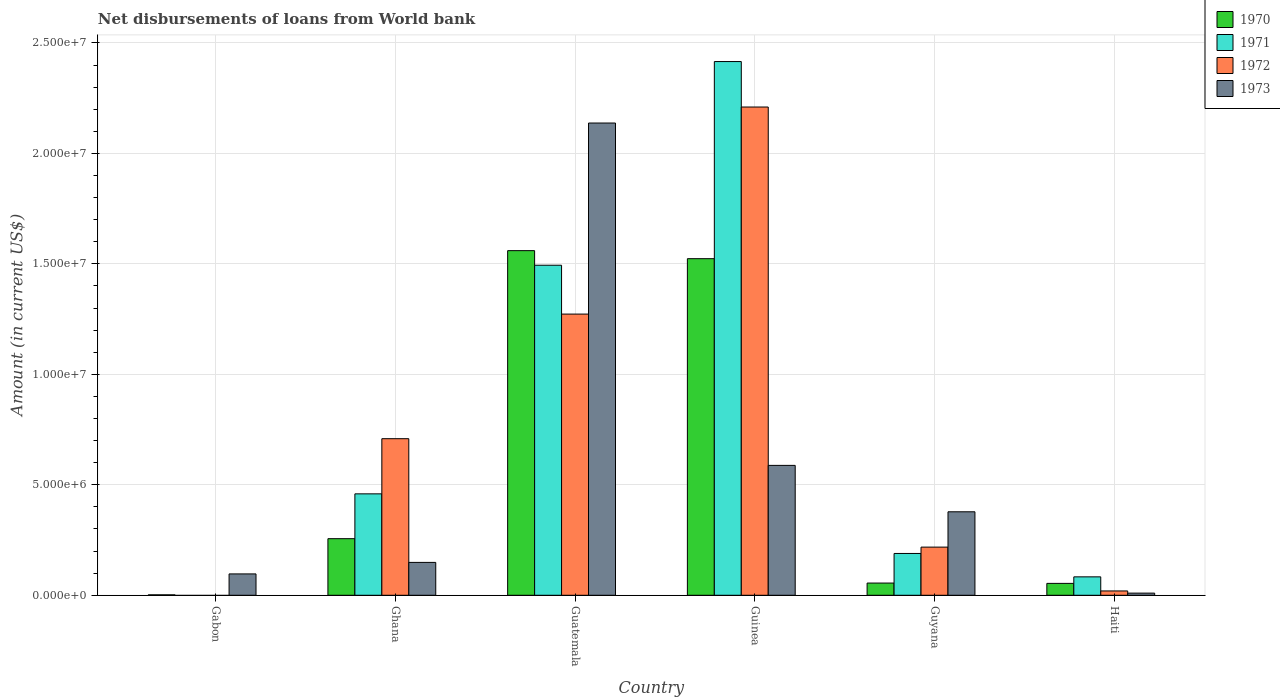How many groups of bars are there?
Provide a short and direct response. 6. Are the number of bars per tick equal to the number of legend labels?
Keep it short and to the point. No. How many bars are there on the 3rd tick from the right?
Make the answer very short. 4. What is the label of the 2nd group of bars from the left?
Provide a succinct answer. Ghana. In how many cases, is the number of bars for a given country not equal to the number of legend labels?
Your response must be concise. 1. What is the amount of loan disbursed from World Bank in 1971 in Guinea?
Provide a short and direct response. 2.42e+07. Across all countries, what is the maximum amount of loan disbursed from World Bank in 1971?
Your answer should be compact. 2.42e+07. Across all countries, what is the minimum amount of loan disbursed from World Bank in 1973?
Make the answer very short. 9.80e+04. In which country was the amount of loan disbursed from World Bank in 1970 maximum?
Your answer should be compact. Guatemala. What is the total amount of loan disbursed from World Bank in 1971 in the graph?
Ensure brevity in your answer.  4.64e+07. What is the difference between the amount of loan disbursed from World Bank in 1970 in Ghana and that in Haiti?
Offer a very short reply. 2.02e+06. What is the difference between the amount of loan disbursed from World Bank in 1972 in Guatemala and the amount of loan disbursed from World Bank in 1971 in Haiti?
Offer a very short reply. 1.19e+07. What is the average amount of loan disbursed from World Bank in 1973 per country?
Your answer should be compact. 5.60e+06. What is the difference between the amount of loan disbursed from World Bank of/in 1970 and amount of loan disbursed from World Bank of/in 1973 in Gabon?
Make the answer very short. -9.47e+05. In how many countries, is the amount of loan disbursed from World Bank in 1971 greater than 24000000 US$?
Make the answer very short. 1. What is the ratio of the amount of loan disbursed from World Bank in 1970 in Gabon to that in Guyana?
Provide a succinct answer. 0.04. What is the difference between the highest and the second highest amount of loan disbursed from World Bank in 1970?
Provide a short and direct response. 3.64e+05. What is the difference between the highest and the lowest amount of loan disbursed from World Bank in 1970?
Your response must be concise. 1.56e+07. Is the sum of the amount of loan disbursed from World Bank in 1973 in Guatemala and Guyana greater than the maximum amount of loan disbursed from World Bank in 1971 across all countries?
Provide a short and direct response. Yes. Is it the case that in every country, the sum of the amount of loan disbursed from World Bank in 1970 and amount of loan disbursed from World Bank in 1973 is greater than the sum of amount of loan disbursed from World Bank in 1971 and amount of loan disbursed from World Bank in 1972?
Make the answer very short. No. Are the values on the major ticks of Y-axis written in scientific E-notation?
Your response must be concise. Yes. Does the graph contain any zero values?
Make the answer very short. Yes. How many legend labels are there?
Provide a short and direct response. 4. What is the title of the graph?
Make the answer very short. Net disbursements of loans from World bank. Does "1991" appear as one of the legend labels in the graph?
Your response must be concise. No. What is the label or title of the X-axis?
Your answer should be compact. Country. What is the label or title of the Y-axis?
Make the answer very short. Amount (in current US$). What is the Amount (in current US$) in 1971 in Gabon?
Provide a short and direct response. 0. What is the Amount (in current US$) of 1973 in Gabon?
Give a very brief answer. 9.67e+05. What is the Amount (in current US$) of 1970 in Ghana?
Your answer should be very brief. 2.56e+06. What is the Amount (in current US$) in 1971 in Ghana?
Offer a terse response. 4.59e+06. What is the Amount (in current US$) of 1972 in Ghana?
Keep it short and to the point. 7.09e+06. What is the Amount (in current US$) of 1973 in Ghana?
Ensure brevity in your answer.  1.49e+06. What is the Amount (in current US$) of 1970 in Guatemala?
Your answer should be compact. 1.56e+07. What is the Amount (in current US$) of 1971 in Guatemala?
Make the answer very short. 1.49e+07. What is the Amount (in current US$) of 1972 in Guatemala?
Ensure brevity in your answer.  1.27e+07. What is the Amount (in current US$) of 1973 in Guatemala?
Make the answer very short. 2.14e+07. What is the Amount (in current US$) of 1970 in Guinea?
Offer a very short reply. 1.52e+07. What is the Amount (in current US$) of 1971 in Guinea?
Your answer should be compact. 2.42e+07. What is the Amount (in current US$) in 1972 in Guinea?
Provide a short and direct response. 2.21e+07. What is the Amount (in current US$) in 1973 in Guinea?
Provide a succinct answer. 5.88e+06. What is the Amount (in current US$) in 1970 in Guyana?
Provide a short and direct response. 5.53e+05. What is the Amount (in current US$) of 1971 in Guyana?
Offer a terse response. 1.89e+06. What is the Amount (in current US$) of 1972 in Guyana?
Your answer should be very brief. 2.18e+06. What is the Amount (in current US$) in 1973 in Guyana?
Offer a terse response. 3.78e+06. What is the Amount (in current US$) in 1970 in Haiti?
Give a very brief answer. 5.38e+05. What is the Amount (in current US$) of 1971 in Haiti?
Offer a terse response. 8.34e+05. What is the Amount (in current US$) in 1972 in Haiti?
Ensure brevity in your answer.  1.96e+05. What is the Amount (in current US$) in 1973 in Haiti?
Offer a very short reply. 9.80e+04. Across all countries, what is the maximum Amount (in current US$) in 1970?
Provide a short and direct response. 1.56e+07. Across all countries, what is the maximum Amount (in current US$) in 1971?
Offer a very short reply. 2.42e+07. Across all countries, what is the maximum Amount (in current US$) of 1972?
Offer a very short reply. 2.21e+07. Across all countries, what is the maximum Amount (in current US$) of 1973?
Your answer should be compact. 2.14e+07. Across all countries, what is the minimum Amount (in current US$) in 1973?
Your response must be concise. 9.80e+04. What is the total Amount (in current US$) in 1970 in the graph?
Make the answer very short. 3.45e+07. What is the total Amount (in current US$) in 1971 in the graph?
Your answer should be compact. 4.64e+07. What is the total Amount (in current US$) of 1972 in the graph?
Your answer should be compact. 4.43e+07. What is the total Amount (in current US$) of 1973 in the graph?
Provide a succinct answer. 3.36e+07. What is the difference between the Amount (in current US$) in 1970 in Gabon and that in Ghana?
Offer a very short reply. -2.54e+06. What is the difference between the Amount (in current US$) of 1973 in Gabon and that in Ghana?
Keep it short and to the point. -5.21e+05. What is the difference between the Amount (in current US$) in 1970 in Gabon and that in Guatemala?
Provide a succinct answer. -1.56e+07. What is the difference between the Amount (in current US$) in 1973 in Gabon and that in Guatemala?
Keep it short and to the point. -2.04e+07. What is the difference between the Amount (in current US$) in 1970 in Gabon and that in Guinea?
Give a very brief answer. -1.52e+07. What is the difference between the Amount (in current US$) of 1973 in Gabon and that in Guinea?
Provide a succinct answer. -4.91e+06. What is the difference between the Amount (in current US$) in 1970 in Gabon and that in Guyana?
Provide a short and direct response. -5.33e+05. What is the difference between the Amount (in current US$) in 1973 in Gabon and that in Guyana?
Offer a terse response. -2.81e+06. What is the difference between the Amount (in current US$) in 1970 in Gabon and that in Haiti?
Offer a terse response. -5.18e+05. What is the difference between the Amount (in current US$) in 1973 in Gabon and that in Haiti?
Provide a short and direct response. 8.69e+05. What is the difference between the Amount (in current US$) in 1970 in Ghana and that in Guatemala?
Provide a short and direct response. -1.30e+07. What is the difference between the Amount (in current US$) in 1971 in Ghana and that in Guatemala?
Offer a very short reply. -1.03e+07. What is the difference between the Amount (in current US$) of 1972 in Ghana and that in Guatemala?
Your response must be concise. -5.64e+06. What is the difference between the Amount (in current US$) in 1973 in Ghana and that in Guatemala?
Offer a terse response. -1.99e+07. What is the difference between the Amount (in current US$) of 1970 in Ghana and that in Guinea?
Your response must be concise. -1.27e+07. What is the difference between the Amount (in current US$) in 1971 in Ghana and that in Guinea?
Your answer should be very brief. -1.96e+07. What is the difference between the Amount (in current US$) of 1972 in Ghana and that in Guinea?
Provide a succinct answer. -1.50e+07. What is the difference between the Amount (in current US$) of 1973 in Ghana and that in Guinea?
Ensure brevity in your answer.  -4.39e+06. What is the difference between the Amount (in current US$) of 1970 in Ghana and that in Guyana?
Your answer should be very brief. 2.01e+06. What is the difference between the Amount (in current US$) of 1971 in Ghana and that in Guyana?
Offer a very short reply. 2.70e+06. What is the difference between the Amount (in current US$) in 1972 in Ghana and that in Guyana?
Provide a short and direct response. 4.91e+06. What is the difference between the Amount (in current US$) of 1973 in Ghana and that in Guyana?
Ensure brevity in your answer.  -2.29e+06. What is the difference between the Amount (in current US$) in 1970 in Ghana and that in Haiti?
Provide a succinct answer. 2.02e+06. What is the difference between the Amount (in current US$) in 1971 in Ghana and that in Haiti?
Offer a very short reply. 3.76e+06. What is the difference between the Amount (in current US$) of 1972 in Ghana and that in Haiti?
Provide a short and direct response. 6.89e+06. What is the difference between the Amount (in current US$) in 1973 in Ghana and that in Haiti?
Provide a short and direct response. 1.39e+06. What is the difference between the Amount (in current US$) of 1970 in Guatemala and that in Guinea?
Offer a very short reply. 3.64e+05. What is the difference between the Amount (in current US$) in 1971 in Guatemala and that in Guinea?
Your answer should be compact. -9.22e+06. What is the difference between the Amount (in current US$) in 1972 in Guatemala and that in Guinea?
Make the answer very short. -9.37e+06. What is the difference between the Amount (in current US$) in 1973 in Guatemala and that in Guinea?
Offer a terse response. 1.55e+07. What is the difference between the Amount (in current US$) of 1970 in Guatemala and that in Guyana?
Keep it short and to the point. 1.50e+07. What is the difference between the Amount (in current US$) of 1971 in Guatemala and that in Guyana?
Your answer should be very brief. 1.30e+07. What is the difference between the Amount (in current US$) of 1972 in Guatemala and that in Guyana?
Provide a succinct answer. 1.05e+07. What is the difference between the Amount (in current US$) in 1973 in Guatemala and that in Guyana?
Your answer should be compact. 1.76e+07. What is the difference between the Amount (in current US$) of 1970 in Guatemala and that in Haiti?
Your answer should be compact. 1.51e+07. What is the difference between the Amount (in current US$) in 1971 in Guatemala and that in Haiti?
Your response must be concise. 1.41e+07. What is the difference between the Amount (in current US$) of 1972 in Guatemala and that in Haiti?
Your answer should be very brief. 1.25e+07. What is the difference between the Amount (in current US$) of 1973 in Guatemala and that in Haiti?
Give a very brief answer. 2.13e+07. What is the difference between the Amount (in current US$) in 1970 in Guinea and that in Guyana?
Keep it short and to the point. 1.47e+07. What is the difference between the Amount (in current US$) of 1971 in Guinea and that in Guyana?
Your response must be concise. 2.23e+07. What is the difference between the Amount (in current US$) in 1972 in Guinea and that in Guyana?
Make the answer very short. 1.99e+07. What is the difference between the Amount (in current US$) in 1973 in Guinea and that in Guyana?
Keep it short and to the point. 2.10e+06. What is the difference between the Amount (in current US$) of 1970 in Guinea and that in Haiti?
Give a very brief answer. 1.47e+07. What is the difference between the Amount (in current US$) in 1971 in Guinea and that in Haiti?
Your response must be concise. 2.33e+07. What is the difference between the Amount (in current US$) of 1972 in Guinea and that in Haiti?
Your answer should be very brief. 2.19e+07. What is the difference between the Amount (in current US$) of 1973 in Guinea and that in Haiti?
Keep it short and to the point. 5.78e+06. What is the difference between the Amount (in current US$) in 1970 in Guyana and that in Haiti?
Ensure brevity in your answer.  1.50e+04. What is the difference between the Amount (in current US$) in 1971 in Guyana and that in Haiti?
Make the answer very short. 1.06e+06. What is the difference between the Amount (in current US$) in 1972 in Guyana and that in Haiti?
Give a very brief answer. 1.98e+06. What is the difference between the Amount (in current US$) in 1973 in Guyana and that in Haiti?
Your response must be concise. 3.68e+06. What is the difference between the Amount (in current US$) of 1970 in Gabon and the Amount (in current US$) of 1971 in Ghana?
Your answer should be compact. -4.57e+06. What is the difference between the Amount (in current US$) of 1970 in Gabon and the Amount (in current US$) of 1972 in Ghana?
Keep it short and to the point. -7.07e+06. What is the difference between the Amount (in current US$) in 1970 in Gabon and the Amount (in current US$) in 1973 in Ghana?
Your response must be concise. -1.47e+06. What is the difference between the Amount (in current US$) of 1970 in Gabon and the Amount (in current US$) of 1971 in Guatemala?
Your answer should be compact. -1.49e+07. What is the difference between the Amount (in current US$) in 1970 in Gabon and the Amount (in current US$) in 1972 in Guatemala?
Your answer should be very brief. -1.27e+07. What is the difference between the Amount (in current US$) of 1970 in Gabon and the Amount (in current US$) of 1973 in Guatemala?
Your response must be concise. -2.14e+07. What is the difference between the Amount (in current US$) of 1970 in Gabon and the Amount (in current US$) of 1971 in Guinea?
Your response must be concise. -2.41e+07. What is the difference between the Amount (in current US$) of 1970 in Gabon and the Amount (in current US$) of 1972 in Guinea?
Offer a terse response. -2.21e+07. What is the difference between the Amount (in current US$) in 1970 in Gabon and the Amount (in current US$) in 1973 in Guinea?
Offer a terse response. -5.86e+06. What is the difference between the Amount (in current US$) of 1970 in Gabon and the Amount (in current US$) of 1971 in Guyana?
Give a very brief answer. -1.87e+06. What is the difference between the Amount (in current US$) of 1970 in Gabon and the Amount (in current US$) of 1972 in Guyana?
Keep it short and to the point. -2.16e+06. What is the difference between the Amount (in current US$) in 1970 in Gabon and the Amount (in current US$) in 1973 in Guyana?
Give a very brief answer. -3.76e+06. What is the difference between the Amount (in current US$) of 1970 in Gabon and the Amount (in current US$) of 1971 in Haiti?
Make the answer very short. -8.14e+05. What is the difference between the Amount (in current US$) of 1970 in Gabon and the Amount (in current US$) of 1972 in Haiti?
Your answer should be very brief. -1.76e+05. What is the difference between the Amount (in current US$) in 1970 in Gabon and the Amount (in current US$) in 1973 in Haiti?
Ensure brevity in your answer.  -7.80e+04. What is the difference between the Amount (in current US$) in 1970 in Ghana and the Amount (in current US$) in 1971 in Guatemala?
Provide a succinct answer. -1.24e+07. What is the difference between the Amount (in current US$) in 1970 in Ghana and the Amount (in current US$) in 1972 in Guatemala?
Ensure brevity in your answer.  -1.02e+07. What is the difference between the Amount (in current US$) in 1970 in Ghana and the Amount (in current US$) in 1973 in Guatemala?
Provide a short and direct response. -1.88e+07. What is the difference between the Amount (in current US$) in 1971 in Ghana and the Amount (in current US$) in 1972 in Guatemala?
Keep it short and to the point. -8.14e+06. What is the difference between the Amount (in current US$) in 1971 in Ghana and the Amount (in current US$) in 1973 in Guatemala?
Offer a very short reply. -1.68e+07. What is the difference between the Amount (in current US$) of 1972 in Ghana and the Amount (in current US$) of 1973 in Guatemala?
Provide a succinct answer. -1.43e+07. What is the difference between the Amount (in current US$) of 1970 in Ghana and the Amount (in current US$) of 1971 in Guinea?
Your answer should be compact. -2.16e+07. What is the difference between the Amount (in current US$) in 1970 in Ghana and the Amount (in current US$) in 1972 in Guinea?
Provide a succinct answer. -1.95e+07. What is the difference between the Amount (in current US$) in 1970 in Ghana and the Amount (in current US$) in 1973 in Guinea?
Provide a short and direct response. -3.32e+06. What is the difference between the Amount (in current US$) in 1971 in Ghana and the Amount (in current US$) in 1972 in Guinea?
Your response must be concise. -1.75e+07. What is the difference between the Amount (in current US$) of 1971 in Ghana and the Amount (in current US$) of 1973 in Guinea?
Your answer should be very brief. -1.29e+06. What is the difference between the Amount (in current US$) in 1972 in Ghana and the Amount (in current US$) in 1973 in Guinea?
Keep it short and to the point. 1.21e+06. What is the difference between the Amount (in current US$) in 1970 in Ghana and the Amount (in current US$) in 1971 in Guyana?
Offer a terse response. 6.69e+05. What is the difference between the Amount (in current US$) in 1970 in Ghana and the Amount (in current US$) in 1972 in Guyana?
Ensure brevity in your answer.  3.82e+05. What is the difference between the Amount (in current US$) in 1970 in Ghana and the Amount (in current US$) in 1973 in Guyana?
Offer a terse response. -1.22e+06. What is the difference between the Amount (in current US$) in 1971 in Ghana and the Amount (in current US$) in 1972 in Guyana?
Provide a short and direct response. 2.41e+06. What is the difference between the Amount (in current US$) in 1971 in Ghana and the Amount (in current US$) in 1973 in Guyana?
Give a very brief answer. 8.12e+05. What is the difference between the Amount (in current US$) in 1972 in Ghana and the Amount (in current US$) in 1973 in Guyana?
Make the answer very short. 3.31e+06. What is the difference between the Amount (in current US$) in 1970 in Ghana and the Amount (in current US$) in 1971 in Haiti?
Keep it short and to the point. 1.73e+06. What is the difference between the Amount (in current US$) in 1970 in Ghana and the Amount (in current US$) in 1972 in Haiti?
Provide a succinct answer. 2.37e+06. What is the difference between the Amount (in current US$) in 1970 in Ghana and the Amount (in current US$) in 1973 in Haiti?
Provide a short and direct response. 2.46e+06. What is the difference between the Amount (in current US$) of 1971 in Ghana and the Amount (in current US$) of 1972 in Haiti?
Offer a very short reply. 4.40e+06. What is the difference between the Amount (in current US$) in 1971 in Ghana and the Amount (in current US$) in 1973 in Haiti?
Your answer should be compact. 4.49e+06. What is the difference between the Amount (in current US$) of 1972 in Ghana and the Amount (in current US$) of 1973 in Haiti?
Your response must be concise. 6.99e+06. What is the difference between the Amount (in current US$) in 1970 in Guatemala and the Amount (in current US$) in 1971 in Guinea?
Offer a very short reply. -8.56e+06. What is the difference between the Amount (in current US$) in 1970 in Guatemala and the Amount (in current US$) in 1972 in Guinea?
Your answer should be compact. -6.50e+06. What is the difference between the Amount (in current US$) in 1970 in Guatemala and the Amount (in current US$) in 1973 in Guinea?
Make the answer very short. 9.72e+06. What is the difference between the Amount (in current US$) in 1971 in Guatemala and the Amount (in current US$) in 1972 in Guinea?
Ensure brevity in your answer.  -7.16e+06. What is the difference between the Amount (in current US$) of 1971 in Guatemala and the Amount (in current US$) of 1973 in Guinea?
Give a very brief answer. 9.06e+06. What is the difference between the Amount (in current US$) in 1972 in Guatemala and the Amount (in current US$) in 1973 in Guinea?
Make the answer very short. 6.85e+06. What is the difference between the Amount (in current US$) in 1970 in Guatemala and the Amount (in current US$) in 1971 in Guyana?
Make the answer very short. 1.37e+07. What is the difference between the Amount (in current US$) in 1970 in Guatemala and the Amount (in current US$) in 1972 in Guyana?
Offer a terse response. 1.34e+07. What is the difference between the Amount (in current US$) in 1970 in Guatemala and the Amount (in current US$) in 1973 in Guyana?
Keep it short and to the point. 1.18e+07. What is the difference between the Amount (in current US$) in 1971 in Guatemala and the Amount (in current US$) in 1972 in Guyana?
Provide a short and direct response. 1.28e+07. What is the difference between the Amount (in current US$) of 1971 in Guatemala and the Amount (in current US$) of 1973 in Guyana?
Give a very brief answer. 1.12e+07. What is the difference between the Amount (in current US$) of 1972 in Guatemala and the Amount (in current US$) of 1973 in Guyana?
Offer a terse response. 8.95e+06. What is the difference between the Amount (in current US$) of 1970 in Guatemala and the Amount (in current US$) of 1971 in Haiti?
Make the answer very short. 1.48e+07. What is the difference between the Amount (in current US$) in 1970 in Guatemala and the Amount (in current US$) in 1972 in Haiti?
Ensure brevity in your answer.  1.54e+07. What is the difference between the Amount (in current US$) of 1970 in Guatemala and the Amount (in current US$) of 1973 in Haiti?
Provide a short and direct response. 1.55e+07. What is the difference between the Amount (in current US$) of 1971 in Guatemala and the Amount (in current US$) of 1972 in Haiti?
Make the answer very short. 1.47e+07. What is the difference between the Amount (in current US$) of 1971 in Guatemala and the Amount (in current US$) of 1973 in Haiti?
Offer a very short reply. 1.48e+07. What is the difference between the Amount (in current US$) in 1972 in Guatemala and the Amount (in current US$) in 1973 in Haiti?
Give a very brief answer. 1.26e+07. What is the difference between the Amount (in current US$) of 1970 in Guinea and the Amount (in current US$) of 1971 in Guyana?
Your answer should be compact. 1.33e+07. What is the difference between the Amount (in current US$) of 1970 in Guinea and the Amount (in current US$) of 1972 in Guyana?
Provide a short and direct response. 1.31e+07. What is the difference between the Amount (in current US$) of 1970 in Guinea and the Amount (in current US$) of 1973 in Guyana?
Make the answer very short. 1.15e+07. What is the difference between the Amount (in current US$) in 1971 in Guinea and the Amount (in current US$) in 1972 in Guyana?
Give a very brief answer. 2.20e+07. What is the difference between the Amount (in current US$) of 1971 in Guinea and the Amount (in current US$) of 1973 in Guyana?
Keep it short and to the point. 2.04e+07. What is the difference between the Amount (in current US$) of 1972 in Guinea and the Amount (in current US$) of 1973 in Guyana?
Offer a very short reply. 1.83e+07. What is the difference between the Amount (in current US$) in 1970 in Guinea and the Amount (in current US$) in 1971 in Haiti?
Make the answer very short. 1.44e+07. What is the difference between the Amount (in current US$) in 1970 in Guinea and the Amount (in current US$) in 1972 in Haiti?
Make the answer very short. 1.50e+07. What is the difference between the Amount (in current US$) of 1970 in Guinea and the Amount (in current US$) of 1973 in Haiti?
Make the answer very short. 1.51e+07. What is the difference between the Amount (in current US$) of 1971 in Guinea and the Amount (in current US$) of 1972 in Haiti?
Offer a very short reply. 2.40e+07. What is the difference between the Amount (in current US$) of 1971 in Guinea and the Amount (in current US$) of 1973 in Haiti?
Keep it short and to the point. 2.41e+07. What is the difference between the Amount (in current US$) in 1972 in Guinea and the Amount (in current US$) in 1973 in Haiti?
Your response must be concise. 2.20e+07. What is the difference between the Amount (in current US$) in 1970 in Guyana and the Amount (in current US$) in 1971 in Haiti?
Keep it short and to the point. -2.81e+05. What is the difference between the Amount (in current US$) of 1970 in Guyana and the Amount (in current US$) of 1972 in Haiti?
Your response must be concise. 3.57e+05. What is the difference between the Amount (in current US$) in 1970 in Guyana and the Amount (in current US$) in 1973 in Haiti?
Your answer should be very brief. 4.55e+05. What is the difference between the Amount (in current US$) of 1971 in Guyana and the Amount (in current US$) of 1972 in Haiti?
Ensure brevity in your answer.  1.70e+06. What is the difference between the Amount (in current US$) in 1971 in Guyana and the Amount (in current US$) in 1973 in Haiti?
Provide a short and direct response. 1.80e+06. What is the difference between the Amount (in current US$) of 1972 in Guyana and the Amount (in current US$) of 1973 in Haiti?
Ensure brevity in your answer.  2.08e+06. What is the average Amount (in current US$) in 1970 per country?
Give a very brief answer. 5.75e+06. What is the average Amount (in current US$) of 1971 per country?
Provide a succinct answer. 7.74e+06. What is the average Amount (in current US$) of 1972 per country?
Make the answer very short. 7.38e+06. What is the average Amount (in current US$) in 1973 per country?
Your answer should be very brief. 5.60e+06. What is the difference between the Amount (in current US$) in 1970 and Amount (in current US$) in 1973 in Gabon?
Offer a very short reply. -9.47e+05. What is the difference between the Amount (in current US$) of 1970 and Amount (in current US$) of 1971 in Ghana?
Your answer should be very brief. -2.03e+06. What is the difference between the Amount (in current US$) in 1970 and Amount (in current US$) in 1972 in Ghana?
Make the answer very short. -4.53e+06. What is the difference between the Amount (in current US$) of 1970 and Amount (in current US$) of 1973 in Ghana?
Your answer should be compact. 1.07e+06. What is the difference between the Amount (in current US$) in 1971 and Amount (in current US$) in 1972 in Ghana?
Offer a terse response. -2.50e+06. What is the difference between the Amount (in current US$) of 1971 and Amount (in current US$) of 1973 in Ghana?
Make the answer very short. 3.10e+06. What is the difference between the Amount (in current US$) in 1972 and Amount (in current US$) in 1973 in Ghana?
Ensure brevity in your answer.  5.60e+06. What is the difference between the Amount (in current US$) in 1970 and Amount (in current US$) in 1971 in Guatemala?
Your answer should be compact. 6.60e+05. What is the difference between the Amount (in current US$) of 1970 and Amount (in current US$) of 1972 in Guatemala?
Your answer should be compact. 2.87e+06. What is the difference between the Amount (in current US$) of 1970 and Amount (in current US$) of 1973 in Guatemala?
Offer a very short reply. -5.78e+06. What is the difference between the Amount (in current US$) in 1971 and Amount (in current US$) in 1972 in Guatemala?
Give a very brief answer. 2.21e+06. What is the difference between the Amount (in current US$) of 1971 and Amount (in current US$) of 1973 in Guatemala?
Provide a short and direct response. -6.44e+06. What is the difference between the Amount (in current US$) of 1972 and Amount (in current US$) of 1973 in Guatemala?
Keep it short and to the point. -8.65e+06. What is the difference between the Amount (in current US$) in 1970 and Amount (in current US$) in 1971 in Guinea?
Ensure brevity in your answer.  -8.92e+06. What is the difference between the Amount (in current US$) of 1970 and Amount (in current US$) of 1972 in Guinea?
Your response must be concise. -6.86e+06. What is the difference between the Amount (in current US$) in 1970 and Amount (in current US$) in 1973 in Guinea?
Your answer should be compact. 9.36e+06. What is the difference between the Amount (in current US$) in 1971 and Amount (in current US$) in 1972 in Guinea?
Your answer should be compact. 2.06e+06. What is the difference between the Amount (in current US$) in 1971 and Amount (in current US$) in 1973 in Guinea?
Your response must be concise. 1.83e+07. What is the difference between the Amount (in current US$) in 1972 and Amount (in current US$) in 1973 in Guinea?
Ensure brevity in your answer.  1.62e+07. What is the difference between the Amount (in current US$) in 1970 and Amount (in current US$) in 1971 in Guyana?
Your answer should be compact. -1.34e+06. What is the difference between the Amount (in current US$) in 1970 and Amount (in current US$) in 1972 in Guyana?
Offer a terse response. -1.63e+06. What is the difference between the Amount (in current US$) in 1970 and Amount (in current US$) in 1973 in Guyana?
Make the answer very short. -3.23e+06. What is the difference between the Amount (in current US$) of 1971 and Amount (in current US$) of 1972 in Guyana?
Make the answer very short. -2.87e+05. What is the difference between the Amount (in current US$) of 1971 and Amount (in current US$) of 1973 in Guyana?
Your answer should be very brief. -1.89e+06. What is the difference between the Amount (in current US$) in 1972 and Amount (in current US$) in 1973 in Guyana?
Keep it short and to the point. -1.60e+06. What is the difference between the Amount (in current US$) in 1970 and Amount (in current US$) in 1971 in Haiti?
Your answer should be compact. -2.96e+05. What is the difference between the Amount (in current US$) in 1970 and Amount (in current US$) in 1972 in Haiti?
Your answer should be compact. 3.42e+05. What is the difference between the Amount (in current US$) in 1970 and Amount (in current US$) in 1973 in Haiti?
Your answer should be compact. 4.40e+05. What is the difference between the Amount (in current US$) in 1971 and Amount (in current US$) in 1972 in Haiti?
Offer a terse response. 6.38e+05. What is the difference between the Amount (in current US$) of 1971 and Amount (in current US$) of 1973 in Haiti?
Keep it short and to the point. 7.36e+05. What is the difference between the Amount (in current US$) in 1972 and Amount (in current US$) in 1973 in Haiti?
Make the answer very short. 9.80e+04. What is the ratio of the Amount (in current US$) in 1970 in Gabon to that in Ghana?
Offer a terse response. 0.01. What is the ratio of the Amount (in current US$) in 1973 in Gabon to that in Ghana?
Provide a succinct answer. 0.65. What is the ratio of the Amount (in current US$) in 1970 in Gabon to that in Guatemala?
Your answer should be very brief. 0. What is the ratio of the Amount (in current US$) in 1973 in Gabon to that in Guatemala?
Provide a short and direct response. 0.05. What is the ratio of the Amount (in current US$) of 1970 in Gabon to that in Guinea?
Offer a very short reply. 0. What is the ratio of the Amount (in current US$) of 1973 in Gabon to that in Guinea?
Give a very brief answer. 0.16. What is the ratio of the Amount (in current US$) in 1970 in Gabon to that in Guyana?
Offer a very short reply. 0.04. What is the ratio of the Amount (in current US$) in 1973 in Gabon to that in Guyana?
Provide a short and direct response. 0.26. What is the ratio of the Amount (in current US$) in 1970 in Gabon to that in Haiti?
Provide a short and direct response. 0.04. What is the ratio of the Amount (in current US$) of 1973 in Gabon to that in Haiti?
Make the answer very short. 9.87. What is the ratio of the Amount (in current US$) of 1970 in Ghana to that in Guatemala?
Ensure brevity in your answer.  0.16. What is the ratio of the Amount (in current US$) in 1971 in Ghana to that in Guatemala?
Your answer should be very brief. 0.31. What is the ratio of the Amount (in current US$) in 1972 in Ghana to that in Guatemala?
Keep it short and to the point. 0.56. What is the ratio of the Amount (in current US$) in 1973 in Ghana to that in Guatemala?
Your response must be concise. 0.07. What is the ratio of the Amount (in current US$) of 1970 in Ghana to that in Guinea?
Your answer should be compact. 0.17. What is the ratio of the Amount (in current US$) in 1971 in Ghana to that in Guinea?
Keep it short and to the point. 0.19. What is the ratio of the Amount (in current US$) of 1972 in Ghana to that in Guinea?
Ensure brevity in your answer.  0.32. What is the ratio of the Amount (in current US$) of 1973 in Ghana to that in Guinea?
Your response must be concise. 0.25. What is the ratio of the Amount (in current US$) in 1970 in Ghana to that in Guyana?
Provide a short and direct response. 4.63. What is the ratio of the Amount (in current US$) in 1971 in Ghana to that in Guyana?
Offer a very short reply. 2.43. What is the ratio of the Amount (in current US$) in 1972 in Ghana to that in Guyana?
Provide a succinct answer. 3.25. What is the ratio of the Amount (in current US$) in 1973 in Ghana to that in Guyana?
Your answer should be compact. 0.39. What is the ratio of the Amount (in current US$) of 1970 in Ghana to that in Haiti?
Keep it short and to the point. 4.76. What is the ratio of the Amount (in current US$) of 1971 in Ghana to that in Haiti?
Provide a succinct answer. 5.5. What is the ratio of the Amount (in current US$) in 1972 in Ghana to that in Haiti?
Your answer should be very brief. 36.16. What is the ratio of the Amount (in current US$) of 1973 in Ghana to that in Haiti?
Offer a terse response. 15.18. What is the ratio of the Amount (in current US$) in 1970 in Guatemala to that in Guinea?
Make the answer very short. 1.02. What is the ratio of the Amount (in current US$) of 1971 in Guatemala to that in Guinea?
Offer a terse response. 0.62. What is the ratio of the Amount (in current US$) in 1972 in Guatemala to that in Guinea?
Make the answer very short. 0.58. What is the ratio of the Amount (in current US$) in 1973 in Guatemala to that in Guinea?
Offer a terse response. 3.64. What is the ratio of the Amount (in current US$) of 1970 in Guatemala to that in Guyana?
Your response must be concise. 28.21. What is the ratio of the Amount (in current US$) in 1971 in Guatemala to that in Guyana?
Provide a short and direct response. 7.89. What is the ratio of the Amount (in current US$) of 1972 in Guatemala to that in Guyana?
Provide a short and direct response. 5.84. What is the ratio of the Amount (in current US$) in 1973 in Guatemala to that in Guyana?
Keep it short and to the point. 5.66. What is the ratio of the Amount (in current US$) of 1970 in Guatemala to that in Haiti?
Make the answer very short. 29. What is the ratio of the Amount (in current US$) of 1971 in Guatemala to that in Haiti?
Keep it short and to the point. 17.91. What is the ratio of the Amount (in current US$) of 1972 in Guatemala to that in Haiti?
Your answer should be very brief. 64.94. What is the ratio of the Amount (in current US$) in 1973 in Guatemala to that in Haiti?
Your answer should be very brief. 218.13. What is the ratio of the Amount (in current US$) in 1970 in Guinea to that in Guyana?
Give a very brief answer. 27.55. What is the ratio of the Amount (in current US$) in 1971 in Guinea to that in Guyana?
Provide a succinct answer. 12.76. What is the ratio of the Amount (in current US$) of 1972 in Guinea to that in Guyana?
Offer a terse response. 10.14. What is the ratio of the Amount (in current US$) of 1973 in Guinea to that in Guyana?
Your answer should be compact. 1.56. What is the ratio of the Amount (in current US$) of 1970 in Guinea to that in Haiti?
Ensure brevity in your answer.  28.32. What is the ratio of the Amount (in current US$) of 1971 in Guinea to that in Haiti?
Your answer should be very brief. 28.97. What is the ratio of the Amount (in current US$) of 1972 in Guinea to that in Haiti?
Provide a succinct answer. 112.76. What is the ratio of the Amount (in current US$) in 1973 in Guinea to that in Haiti?
Offer a terse response. 60. What is the ratio of the Amount (in current US$) in 1970 in Guyana to that in Haiti?
Your answer should be very brief. 1.03. What is the ratio of the Amount (in current US$) of 1971 in Guyana to that in Haiti?
Keep it short and to the point. 2.27. What is the ratio of the Amount (in current US$) in 1972 in Guyana to that in Haiti?
Make the answer very short. 11.12. What is the ratio of the Amount (in current US$) of 1973 in Guyana to that in Haiti?
Keep it short and to the point. 38.56. What is the difference between the highest and the second highest Amount (in current US$) of 1970?
Provide a succinct answer. 3.64e+05. What is the difference between the highest and the second highest Amount (in current US$) of 1971?
Your answer should be compact. 9.22e+06. What is the difference between the highest and the second highest Amount (in current US$) of 1972?
Provide a succinct answer. 9.37e+06. What is the difference between the highest and the second highest Amount (in current US$) of 1973?
Your response must be concise. 1.55e+07. What is the difference between the highest and the lowest Amount (in current US$) of 1970?
Provide a short and direct response. 1.56e+07. What is the difference between the highest and the lowest Amount (in current US$) in 1971?
Your answer should be very brief. 2.42e+07. What is the difference between the highest and the lowest Amount (in current US$) in 1972?
Ensure brevity in your answer.  2.21e+07. What is the difference between the highest and the lowest Amount (in current US$) in 1973?
Keep it short and to the point. 2.13e+07. 